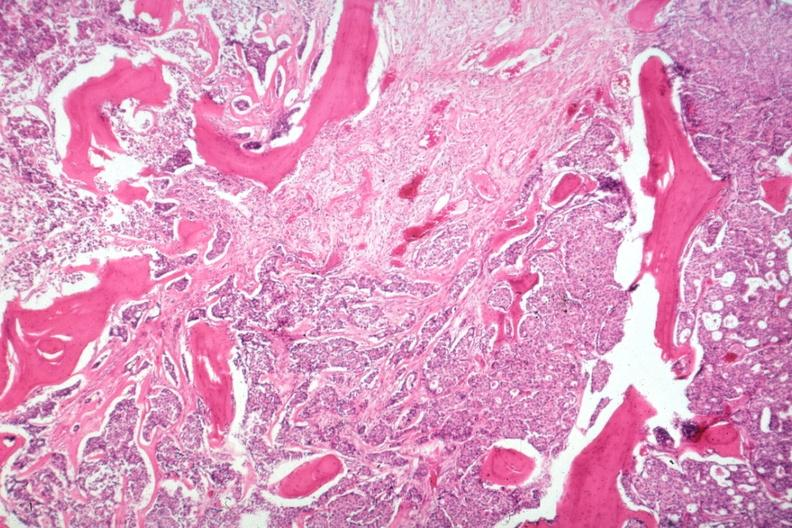what does this image show?
Answer the question using a single word or phrase. Vertebral body gross is islands of tumor with stimulated new bone formation a desmoplastic reaction to the tumor additional micros are and 